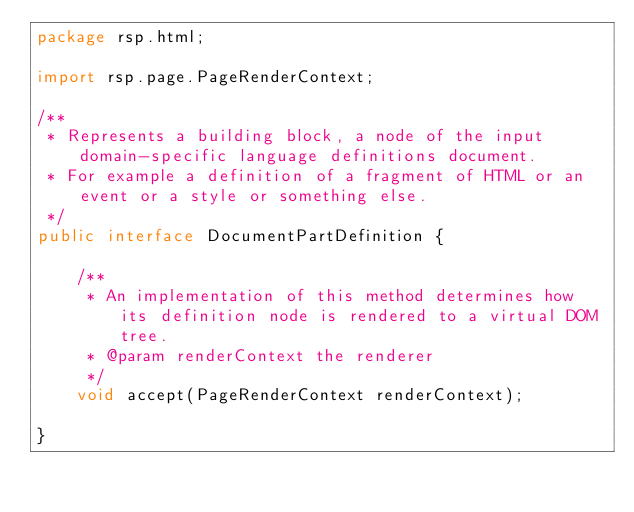Convert code to text. <code><loc_0><loc_0><loc_500><loc_500><_Java_>package rsp.html;

import rsp.page.PageRenderContext;

/**
 * Represents a building block, a node of the input domain-specific language definitions document.
 * For example a definition of a fragment of HTML or an event or a style or something else.
 */
public interface DocumentPartDefinition {

    /**
     * An implementation of this method determines how its definition node is rendered to a virtual DOM tree.
     * @param renderContext the renderer
     */
    void accept(PageRenderContext renderContext);

}
</code> 